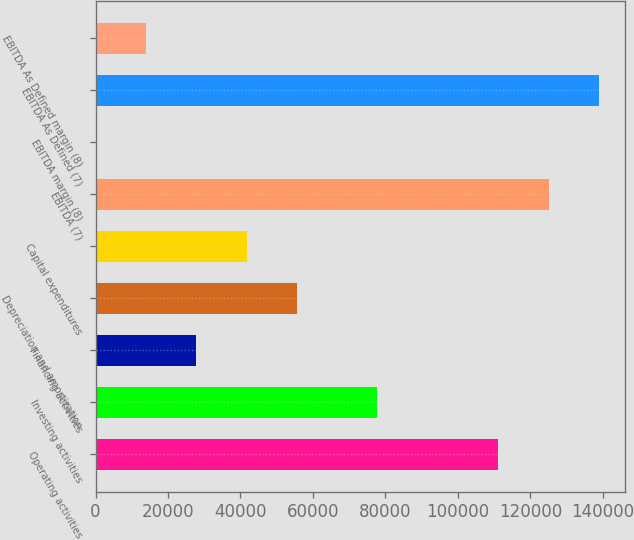Convert chart to OTSL. <chart><loc_0><loc_0><loc_500><loc_500><bar_chart><fcel>Operating activities<fcel>Investing activities<fcel>Financing activities<fcel>Depreciation and amortization<fcel>Capital expenditures<fcel>EBITDA (7)<fcel>EBITDA margin (8)<fcel>EBITDA As Defined (7)<fcel>EBITDA As Defined margin (8)<nl><fcel>111139<fcel>77619<fcel>27847<fcel>55656.2<fcel>41751.6<fcel>125044<fcel>37.7<fcel>139084<fcel>13942.3<nl></chart> 